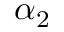<formula> <loc_0><loc_0><loc_500><loc_500>\alpha _ { 2 }</formula> 